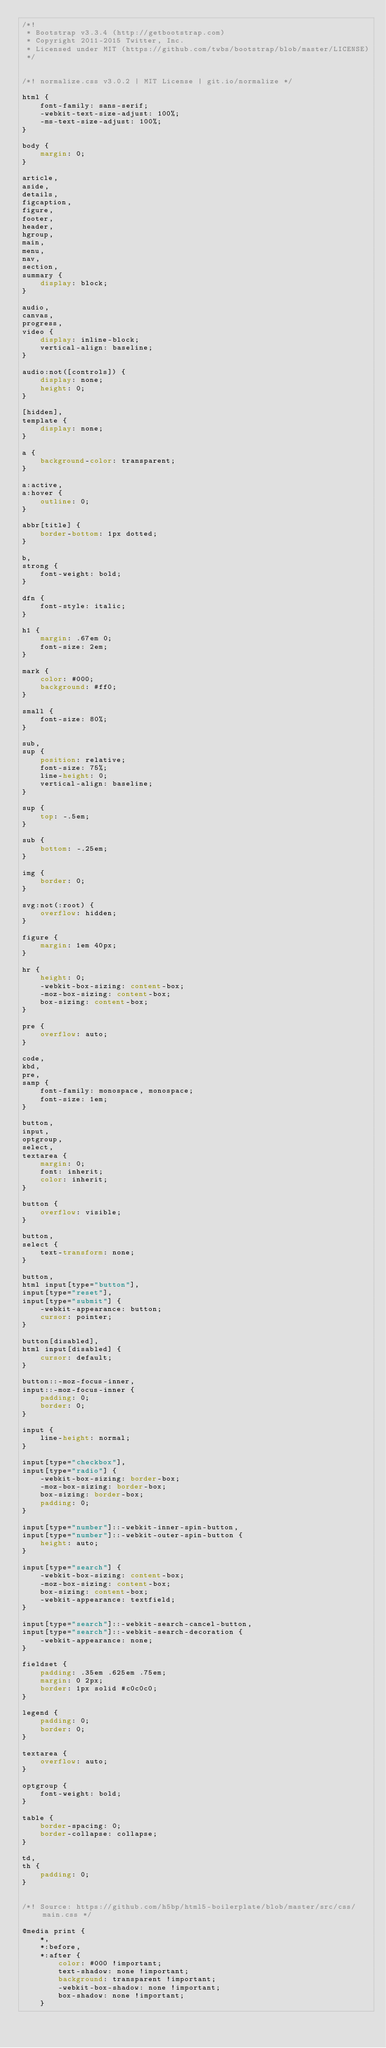<code> <loc_0><loc_0><loc_500><loc_500><_CSS_>/*!
 * Bootstrap v3.3.4 (http://getbootstrap.com)
 * Copyright 2011-2015 Twitter, Inc.
 * Licensed under MIT (https://github.com/twbs/bootstrap/blob/master/LICENSE)
 */


/*! normalize.css v3.0.2 | MIT License | git.io/normalize */

html {
    font-family: sans-serif;
    -webkit-text-size-adjust: 100%;
    -ms-text-size-adjust: 100%;
}

body {
    margin: 0;
}

article,
aside,
details,
figcaption,
figure,
footer,
header,
hgroup,
main,
menu,
nav,
section,
summary {
    display: block;
}

audio,
canvas,
progress,
video {
    display: inline-block;
    vertical-align: baseline;
}

audio:not([controls]) {
    display: none;
    height: 0;
}

[hidden],
template {
    display: none;
}

a {
    background-color: transparent;
}

a:active,
a:hover {
    outline: 0;
}

abbr[title] {
    border-bottom: 1px dotted;
}

b,
strong {
    font-weight: bold;
}

dfn {
    font-style: italic;
}

h1 {
    margin: .67em 0;
    font-size: 2em;
}

mark {
    color: #000;
    background: #ff0;
}

small {
    font-size: 80%;
}

sub,
sup {
    position: relative;
    font-size: 75%;
    line-height: 0;
    vertical-align: baseline;
}

sup {
    top: -.5em;
}

sub {
    bottom: -.25em;
}

img {
    border: 0;
}

svg:not(:root) {
    overflow: hidden;
}

figure {
    margin: 1em 40px;
}

hr {
    height: 0;
    -webkit-box-sizing: content-box;
    -moz-box-sizing: content-box;
    box-sizing: content-box;
}

pre {
    overflow: auto;
}

code,
kbd,
pre,
samp {
    font-family: monospace, monospace;
    font-size: 1em;
}

button,
input,
optgroup,
select,
textarea {
    margin: 0;
    font: inherit;
    color: inherit;
}

button {
    overflow: visible;
}

button,
select {
    text-transform: none;
}

button,
html input[type="button"],
input[type="reset"],
input[type="submit"] {
    -webkit-appearance: button;
    cursor: pointer;
}

button[disabled],
html input[disabled] {
    cursor: default;
}

button::-moz-focus-inner,
input::-moz-focus-inner {
    padding: 0;
    border: 0;
}

input {
    line-height: normal;
}

input[type="checkbox"],
input[type="radio"] {
    -webkit-box-sizing: border-box;
    -moz-box-sizing: border-box;
    box-sizing: border-box;
    padding: 0;
}

input[type="number"]::-webkit-inner-spin-button,
input[type="number"]::-webkit-outer-spin-button {
    height: auto;
}

input[type="search"] {
    -webkit-box-sizing: content-box;
    -moz-box-sizing: content-box;
    box-sizing: content-box;
    -webkit-appearance: textfield;
}

input[type="search"]::-webkit-search-cancel-button,
input[type="search"]::-webkit-search-decoration {
    -webkit-appearance: none;
}

fieldset {
    padding: .35em .625em .75em;
    margin: 0 2px;
    border: 1px solid #c0c0c0;
}

legend {
    padding: 0;
    border: 0;
}

textarea {
    overflow: auto;
}

optgroup {
    font-weight: bold;
}

table {
    border-spacing: 0;
    border-collapse: collapse;
}

td,
th {
    padding: 0;
}


/*! Source: https://github.com/h5bp/html5-boilerplate/blob/master/src/css/main.css */

@media print {
    *,
    *:before,
    *:after {
        color: #000 !important;
        text-shadow: none !important;
        background: transparent !important;
        -webkit-box-shadow: none !important;
        box-shadow: none !important;
    }</code> 